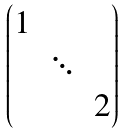Convert formula to latex. <formula><loc_0><loc_0><loc_500><loc_500>\begin{pmatrix} 1 & & \\ & \ddots & \\ & & 2 \end{pmatrix}</formula> 